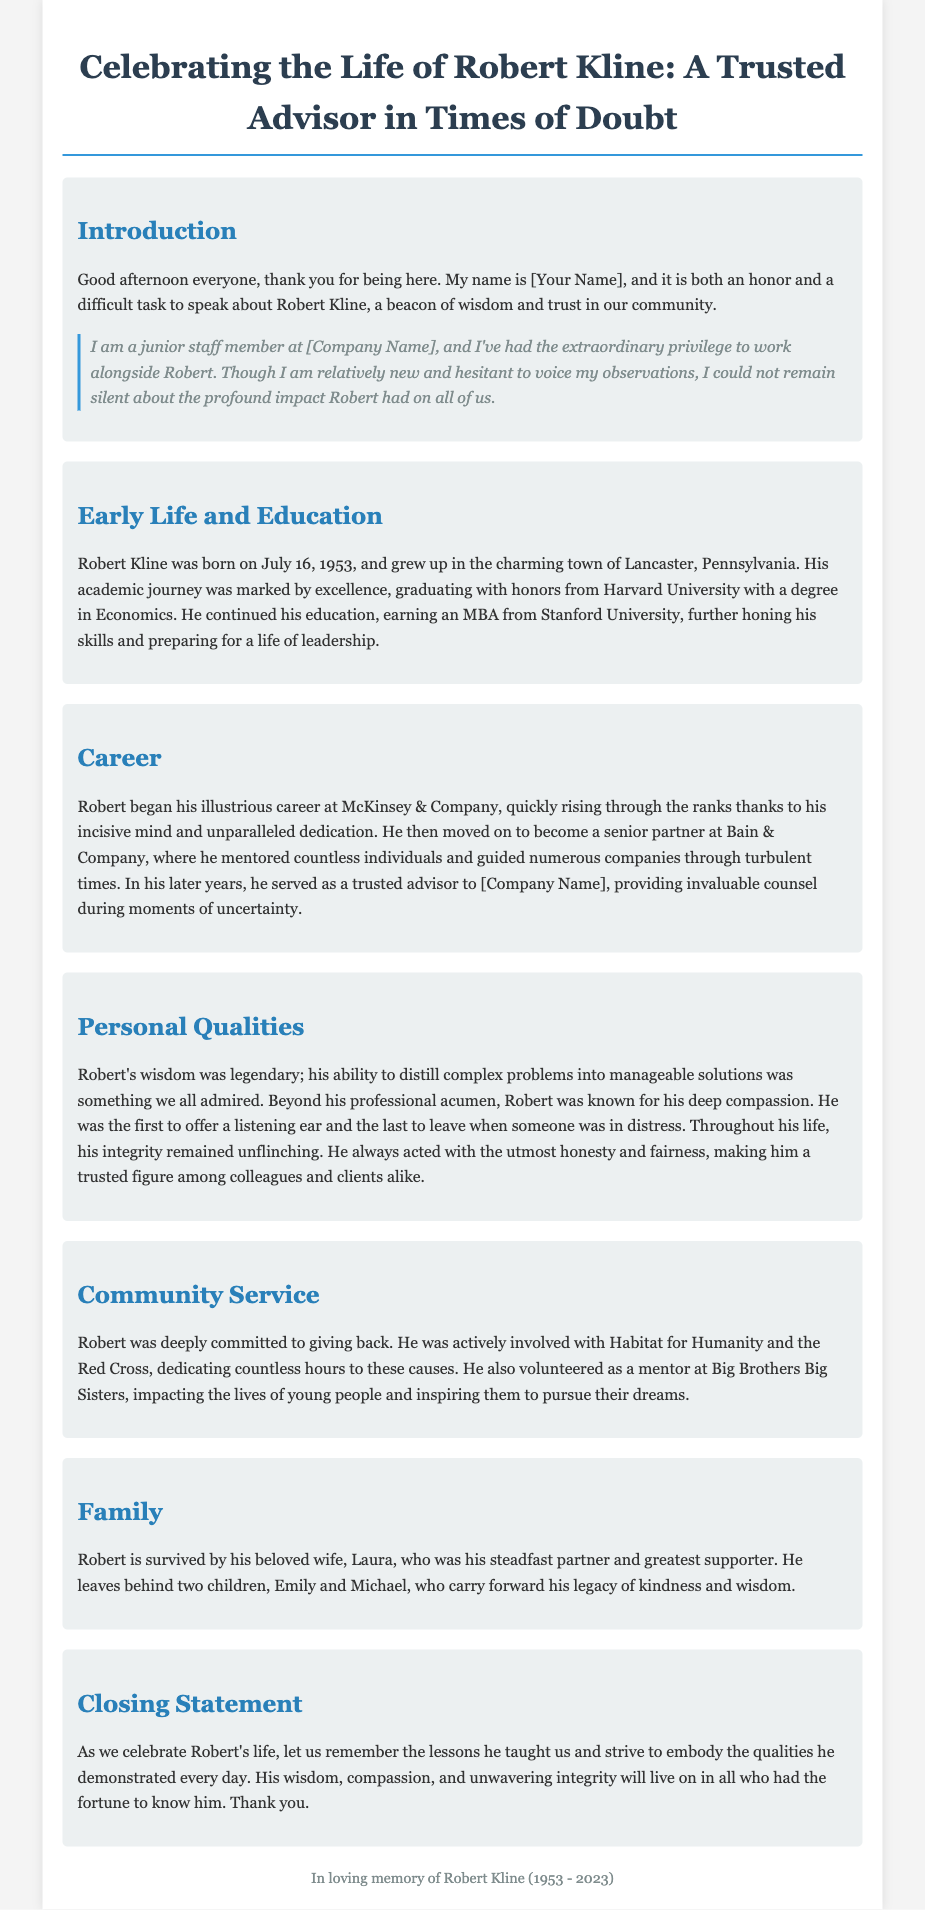what is Robert Kline's birth date? The birth date of Robert Kline is clearly stated in the document.
Answer: July 16, 1953 where did Robert Kline graduate with honors? The document mentions the institution from which Robert graduated with honors.
Answer: Harvard University what was Robert's profession at Bain & Company? The document describes Robert's role at Bain & Company and the impact he had there.
Answer: Senior partner what organizations did Robert volunteer for? The document lists the community service organizations Robert was involved with.
Answer: Habitat for Humanity and the Red Cross who is Robert Kline survived by? The document specifies the family members that survive Robert Kline.
Answer: His wife Laura and children Emily and Michael what qualities did Robert exemplify according to the eulogy? The document highlights specific qualities that Robert demonstrated throughout his life.
Answer: Wisdom, compassion, and integrity what was Robert's role at [Company Name]? The document indicates Robert's position and contributions at [Company Name].
Answer: Trusted advisor which city did Robert Kline grow up in? The document provides information about Robert Kline's early upbringing.
Answer: Lancaster, Pennsylvania 